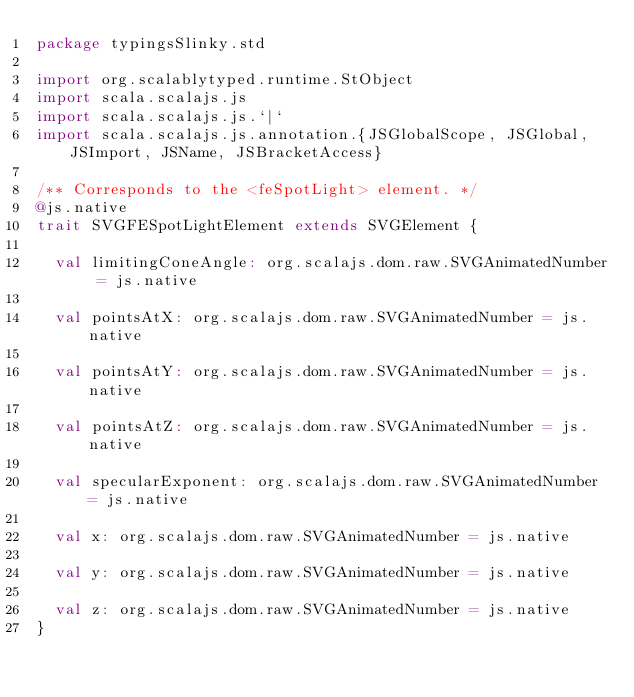Convert code to text. <code><loc_0><loc_0><loc_500><loc_500><_Scala_>package typingsSlinky.std

import org.scalablytyped.runtime.StObject
import scala.scalajs.js
import scala.scalajs.js.`|`
import scala.scalajs.js.annotation.{JSGlobalScope, JSGlobal, JSImport, JSName, JSBracketAccess}

/** Corresponds to the <feSpotLight> element. */
@js.native
trait SVGFESpotLightElement extends SVGElement {
  
  val limitingConeAngle: org.scalajs.dom.raw.SVGAnimatedNumber = js.native
  
  val pointsAtX: org.scalajs.dom.raw.SVGAnimatedNumber = js.native
  
  val pointsAtY: org.scalajs.dom.raw.SVGAnimatedNumber = js.native
  
  val pointsAtZ: org.scalajs.dom.raw.SVGAnimatedNumber = js.native
  
  val specularExponent: org.scalajs.dom.raw.SVGAnimatedNumber = js.native
  
  val x: org.scalajs.dom.raw.SVGAnimatedNumber = js.native
  
  val y: org.scalajs.dom.raw.SVGAnimatedNumber = js.native
  
  val z: org.scalajs.dom.raw.SVGAnimatedNumber = js.native
}
</code> 